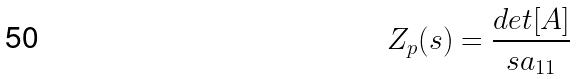Convert formula to latex. <formula><loc_0><loc_0><loc_500><loc_500>Z _ { p } ( s ) = \frac { d e t [ A ] } { s a _ { 1 1 } }</formula> 